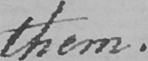What is written in this line of handwriting? them . 